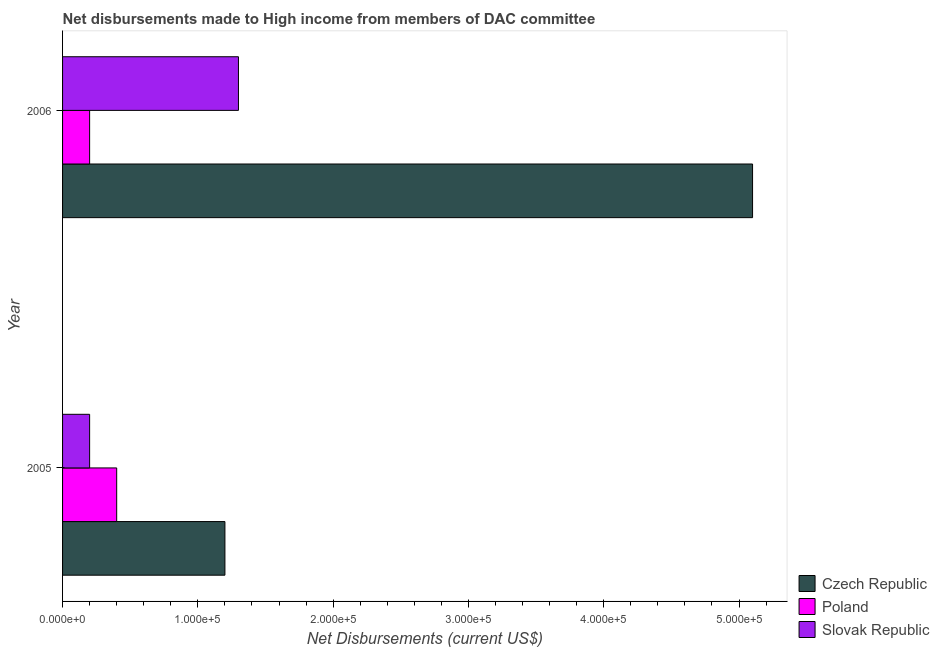Are the number of bars per tick equal to the number of legend labels?
Your answer should be very brief. Yes. Are the number of bars on each tick of the Y-axis equal?
Provide a short and direct response. Yes. How many bars are there on the 1st tick from the bottom?
Your response must be concise. 3. What is the label of the 2nd group of bars from the top?
Keep it short and to the point. 2005. What is the net disbursements made by slovak republic in 2006?
Make the answer very short. 1.30e+05. Across all years, what is the maximum net disbursements made by czech republic?
Provide a succinct answer. 5.10e+05. Across all years, what is the minimum net disbursements made by poland?
Your answer should be compact. 2.00e+04. What is the total net disbursements made by czech republic in the graph?
Provide a short and direct response. 6.30e+05. What is the difference between the net disbursements made by slovak republic in 2005 and that in 2006?
Offer a terse response. -1.10e+05. What is the difference between the net disbursements made by czech republic in 2006 and the net disbursements made by slovak republic in 2005?
Provide a short and direct response. 4.90e+05. What is the average net disbursements made by slovak republic per year?
Keep it short and to the point. 7.50e+04. In the year 2005, what is the difference between the net disbursements made by czech republic and net disbursements made by poland?
Ensure brevity in your answer.  8.00e+04. In how many years, is the net disbursements made by poland greater than 340000 US$?
Provide a succinct answer. 0. What is the ratio of the net disbursements made by czech republic in 2005 to that in 2006?
Make the answer very short. 0.23. Is the net disbursements made by slovak republic in 2005 less than that in 2006?
Keep it short and to the point. Yes. What does the 1st bar from the top in 2006 represents?
Provide a succinct answer. Slovak Republic. What does the 1st bar from the bottom in 2005 represents?
Ensure brevity in your answer.  Czech Republic. Is it the case that in every year, the sum of the net disbursements made by czech republic and net disbursements made by poland is greater than the net disbursements made by slovak republic?
Offer a terse response. Yes. How many bars are there?
Offer a terse response. 6. Are all the bars in the graph horizontal?
Make the answer very short. Yes. How many years are there in the graph?
Provide a short and direct response. 2. What is the difference between two consecutive major ticks on the X-axis?
Give a very brief answer. 1.00e+05. Are the values on the major ticks of X-axis written in scientific E-notation?
Offer a terse response. Yes. Does the graph contain any zero values?
Give a very brief answer. No. Does the graph contain grids?
Provide a succinct answer. No. How many legend labels are there?
Your answer should be compact. 3. What is the title of the graph?
Your response must be concise. Net disbursements made to High income from members of DAC committee. What is the label or title of the X-axis?
Give a very brief answer. Net Disbursements (current US$). What is the Net Disbursements (current US$) in Czech Republic in 2005?
Offer a terse response. 1.20e+05. What is the Net Disbursements (current US$) of Poland in 2005?
Ensure brevity in your answer.  4.00e+04. What is the Net Disbursements (current US$) in Czech Republic in 2006?
Provide a short and direct response. 5.10e+05. Across all years, what is the maximum Net Disbursements (current US$) in Czech Republic?
Your answer should be very brief. 5.10e+05. Across all years, what is the maximum Net Disbursements (current US$) in Slovak Republic?
Keep it short and to the point. 1.30e+05. Across all years, what is the minimum Net Disbursements (current US$) in Czech Republic?
Keep it short and to the point. 1.20e+05. Across all years, what is the minimum Net Disbursements (current US$) of Slovak Republic?
Your answer should be very brief. 2.00e+04. What is the total Net Disbursements (current US$) in Czech Republic in the graph?
Your answer should be very brief. 6.30e+05. What is the difference between the Net Disbursements (current US$) in Czech Republic in 2005 and that in 2006?
Your answer should be compact. -3.90e+05. What is the difference between the Net Disbursements (current US$) in Poland in 2005 and that in 2006?
Keep it short and to the point. 2.00e+04. What is the difference between the Net Disbursements (current US$) of Slovak Republic in 2005 and that in 2006?
Your answer should be very brief. -1.10e+05. What is the difference between the Net Disbursements (current US$) of Czech Republic in 2005 and the Net Disbursements (current US$) of Poland in 2006?
Your response must be concise. 1.00e+05. What is the difference between the Net Disbursements (current US$) of Czech Republic in 2005 and the Net Disbursements (current US$) of Slovak Republic in 2006?
Make the answer very short. -10000. What is the difference between the Net Disbursements (current US$) in Poland in 2005 and the Net Disbursements (current US$) in Slovak Republic in 2006?
Keep it short and to the point. -9.00e+04. What is the average Net Disbursements (current US$) of Czech Republic per year?
Give a very brief answer. 3.15e+05. What is the average Net Disbursements (current US$) of Poland per year?
Keep it short and to the point. 3.00e+04. What is the average Net Disbursements (current US$) in Slovak Republic per year?
Make the answer very short. 7.50e+04. In the year 2005, what is the difference between the Net Disbursements (current US$) of Czech Republic and Net Disbursements (current US$) of Poland?
Provide a short and direct response. 8.00e+04. In the year 2005, what is the difference between the Net Disbursements (current US$) of Czech Republic and Net Disbursements (current US$) of Slovak Republic?
Your response must be concise. 1.00e+05. In the year 2005, what is the difference between the Net Disbursements (current US$) of Poland and Net Disbursements (current US$) of Slovak Republic?
Ensure brevity in your answer.  2.00e+04. In the year 2006, what is the difference between the Net Disbursements (current US$) in Czech Republic and Net Disbursements (current US$) in Slovak Republic?
Offer a terse response. 3.80e+05. In the year 2006, what is the difference between the Net Disbursements (current US$) of Poland and Net Disbursements (current US$) of Slovak Republic?
Ensure brevity in your answer.  -1.10e+05. What is the ratio of the Net Disbursements (current US$) of Czech Republic in 2005 to that in 2006?
Provide a short and direct response. 0.24. What is the ratio of the Net Disbursements (current US$) in Slovak Republic in 2005 to that in 2006?
Provide a succinct answer. 0.15. What is the difference between the highest and the second highest Net Disbursements (current US$) of Czech Republic?
Offer a very short reply. 3.90e+05. What is the difference between the highest and the second highest Net Disbursements (current US$) in Poland?
Offer a very short reply. 2.00e+04. What is the difference between the highest and the lowest Net Disbursements (current US$) of Czech Republic?
Make the answer very short. 3.90e+05. What is the difference between the highest and the lowest Net Disbursements (current US$) in Poland?
Your answer should be very brief. 2.00e+04. 